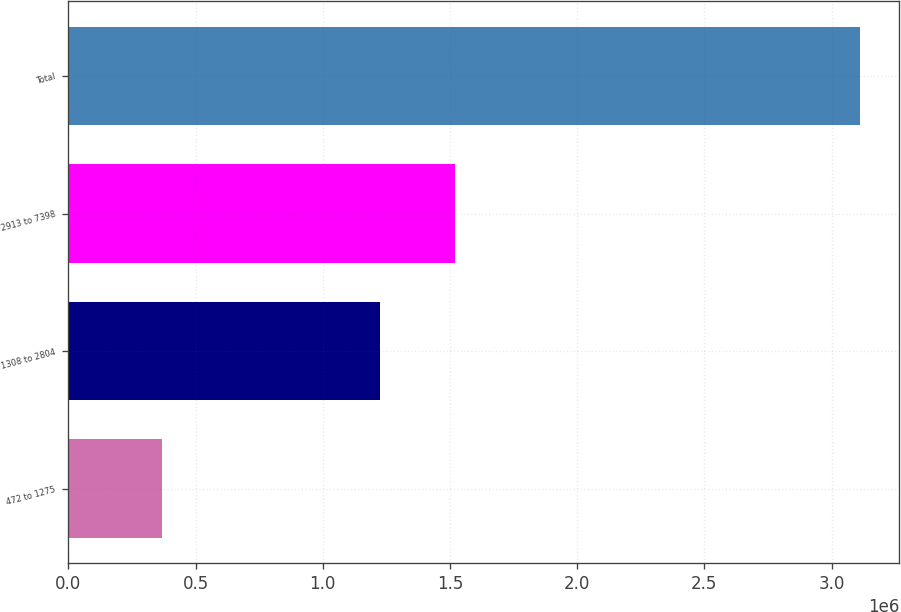Convert chart. <chart><loc_0><loc_0><loc_500><loc_500><bar_chart><fcel>472 to 1275<fcel>1308 to 2804<fcel>2913 to 7398<fcel>Total<nl><fcel>366523<fcel>1.22473e+06<fcel>1.51921e+06<fcel>3.11046e+06<nl></chart> 